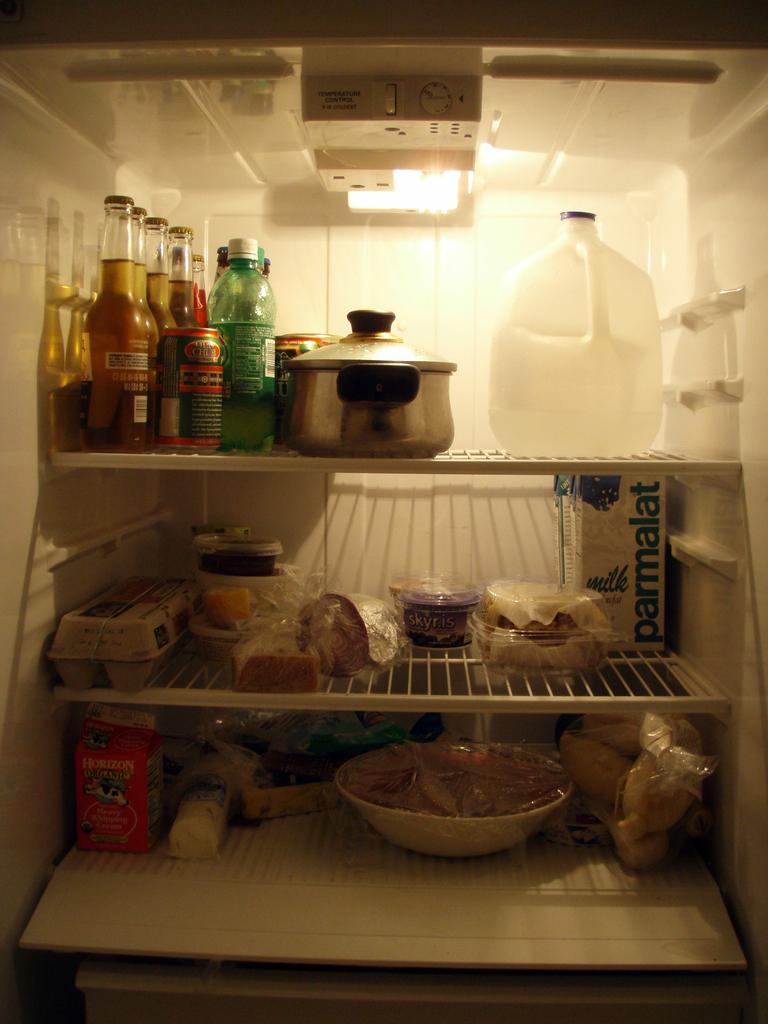What is the brand of the food item on the right in the middle rack?
Provide a short and direct response. Parmalat. Fast food items?
Give a very brief answer. No. 